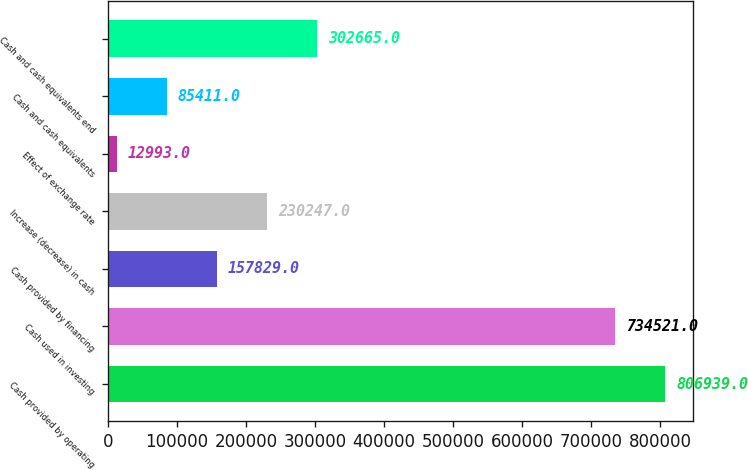<chart> <loc_0><loc_0><loc_500><loc_500><bar_chart><fcel>Cash provided by operating<fcel>Cash used in investing<fcel>Cash provided by financing<fcel>Increase (decrease) in cash<fcel>Effect of exchange rate<fcel>Cash and cash equivalents<fcel>Cash and cash equivalents end<nl><fcel>806939<fcel>734521<fcel>157829<fcel>230247<fcel>12993<fcel>85411<fcel>302665<nl></chart> 